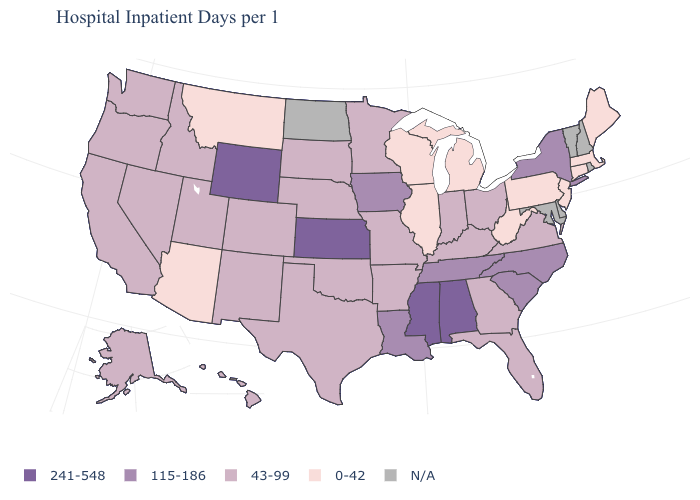Does Montana have the lowest value in the West?
Write a very short answer. Yes. Which states have the highest value in the USA?
Answer briefly. Alabama, Kansas, Mississippi, Wyoming. What is the value of Mississippi?
Answer briefly. 241-548. What is the value of West Virginia?
Quick response, please. 0-42. What is the lowest value in the West?
Short answer required. 0-42. Name the states that have a value in the range 115-186?
Answer briefly. Iowa, Louisiana, New York, North Carolina, South Carolina, Tennessee. Which states hav the highest value in the Northeast?
Write a very short answer. New York. Which states have the lowest value in the Northeast?
Give a very brief answer. Connecticut, Maine, Massachusetts, New Jersey, Pennsylvania. What is the value of South Carolina?
Short answer required. 115-186. Does Pennsylvania have the lowest value in the USA?
Be succinct. Yes. Does Florida have the highest value in the USA?
Write a very short answer. No. What is the value of California?
Concise answer only. 43-99. What is the value of Massachusetts?
Be succinct. 0-42. What is the value of Florida?
Be succinct. 43-99. Does Missouri have the lowest value in the USA?
Short answer required. No. 